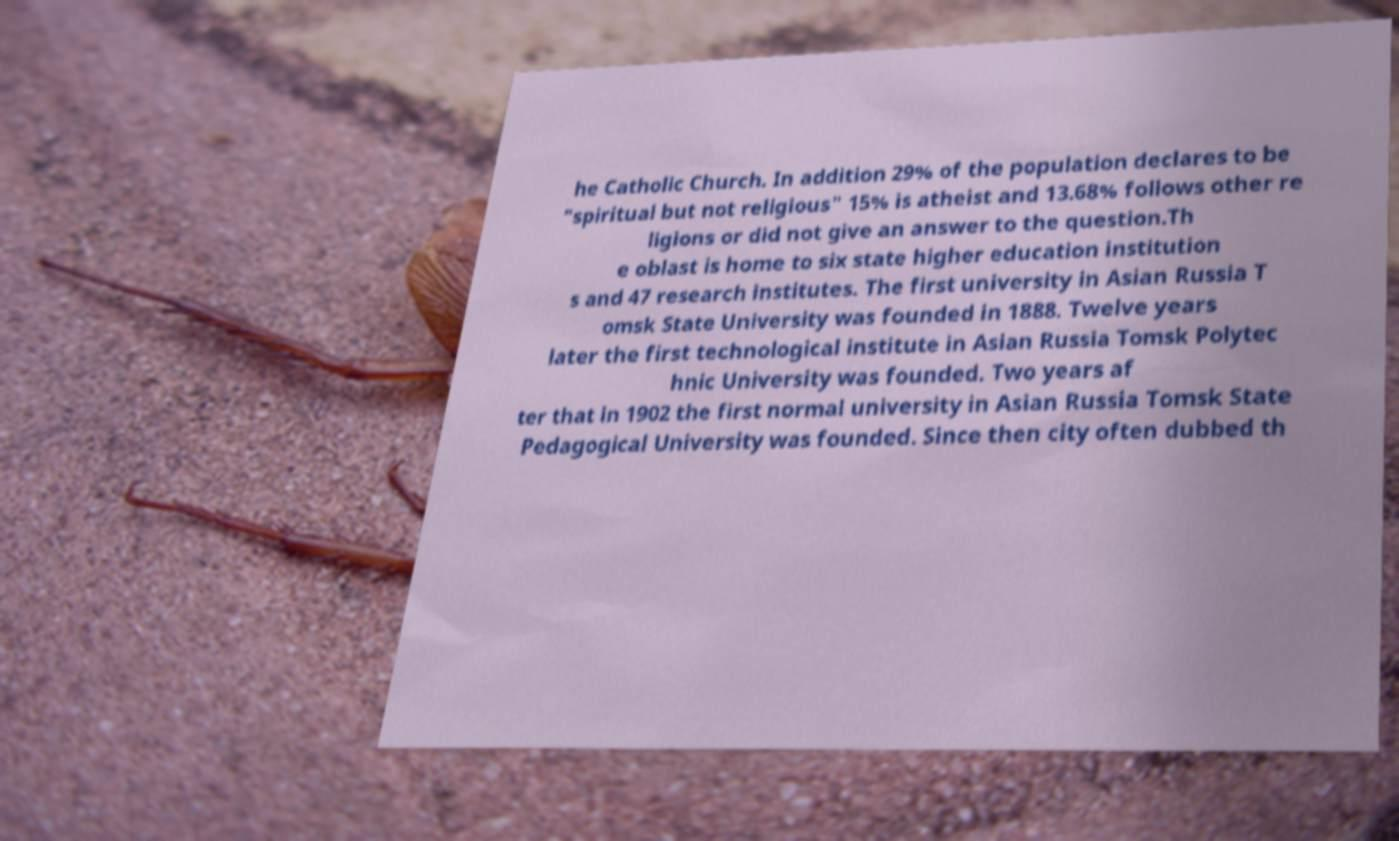What messages or text are displayed in this image? I need them in a readable, typed format. he Catholic Church. In addition 29% of the population declares to be "spiritual but not religious" 15% is atheist and 13.68% follows other re ligions or did not give an answer to the question.Th e oblast is home to six state higher education institution s and 47 research institutes. The first university in Asian Russia T omsk State University was founded in 1888. Twelve years later the first technological institute in Asian Russia Tomsk Polytec hnic University was founded. Two years af ter that in 1902 the first normal university in Asian Russia Tomsk State Pedagogical University was founded. Since then city often dubbed th 